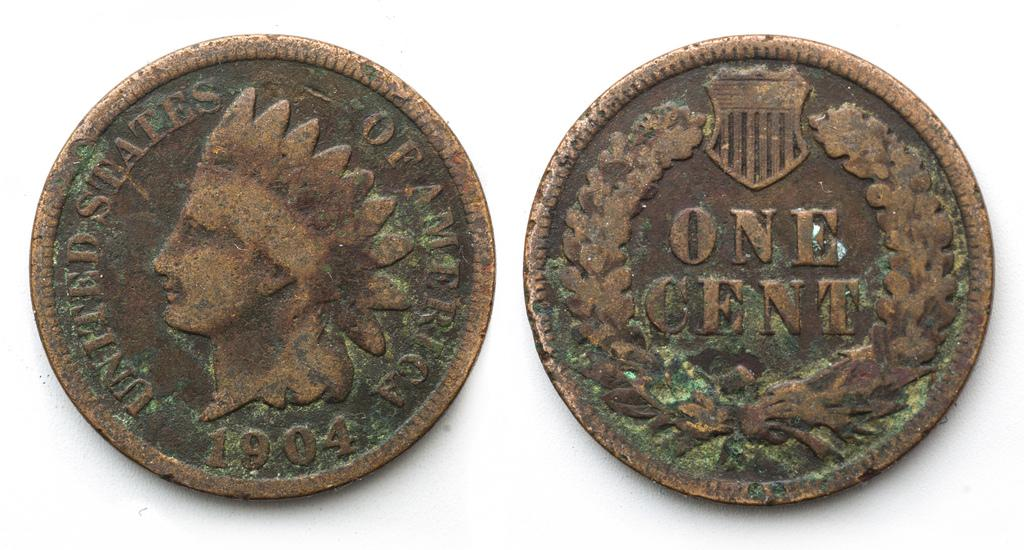<image>
Share a concise interpretation of the image provided. A United States Indian one cent coin from a long time ago. 